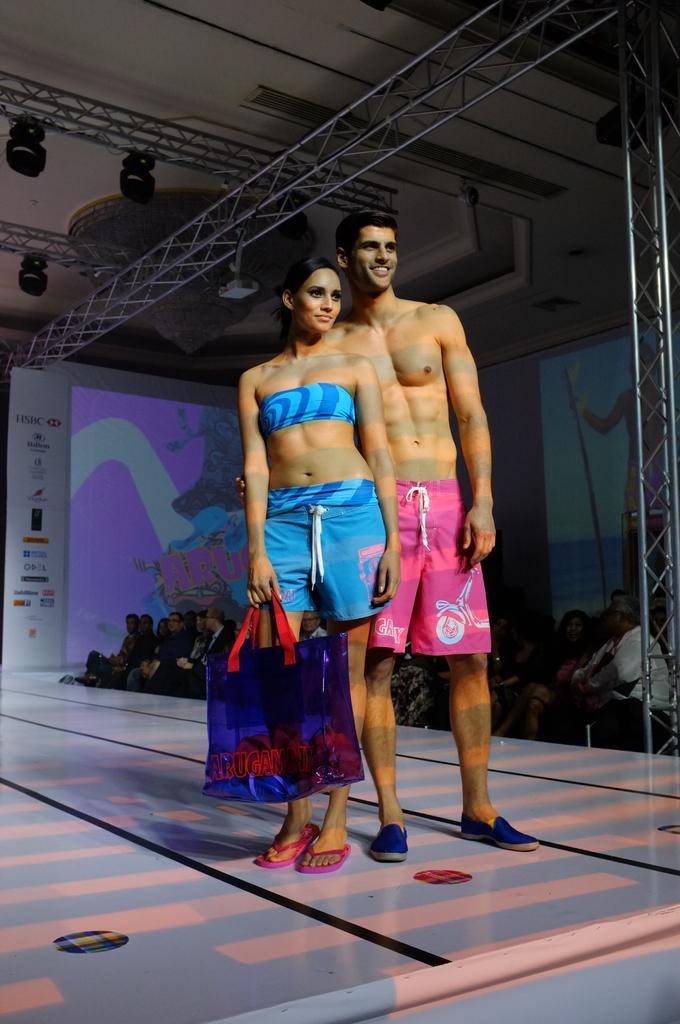Please provide a concise description of this image. These two people are standing on a stage. This woman is holding a bag. Here we can see a hoarding, focusing lights, rods, screens, chandelier and audience. 